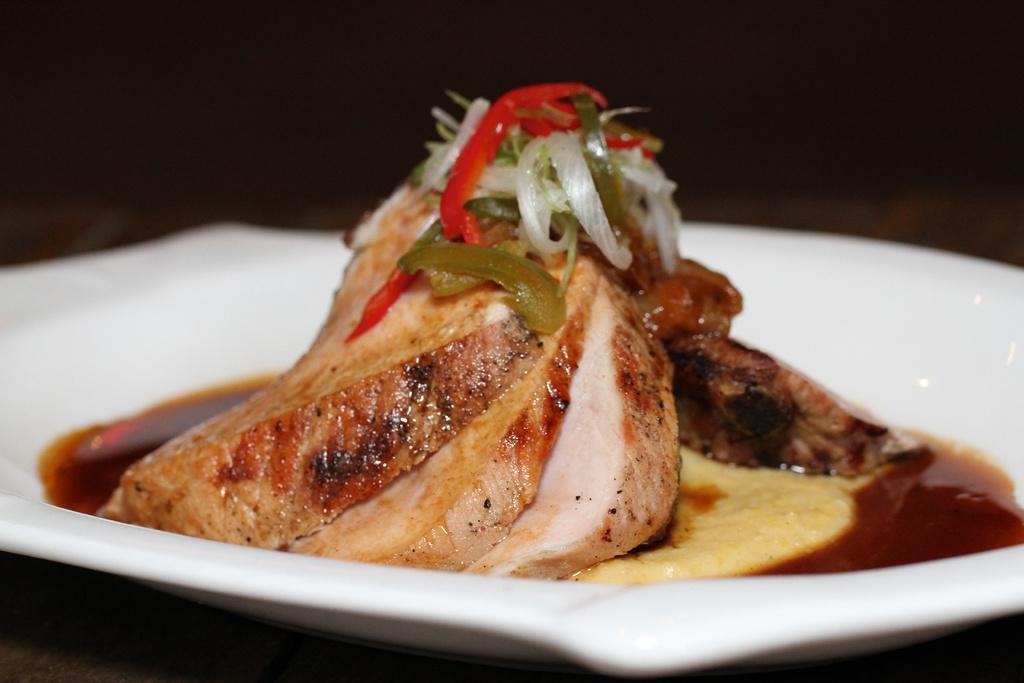Describe this image in one or two sentences. In this image we can see some food on the white plate and the background is dark. 